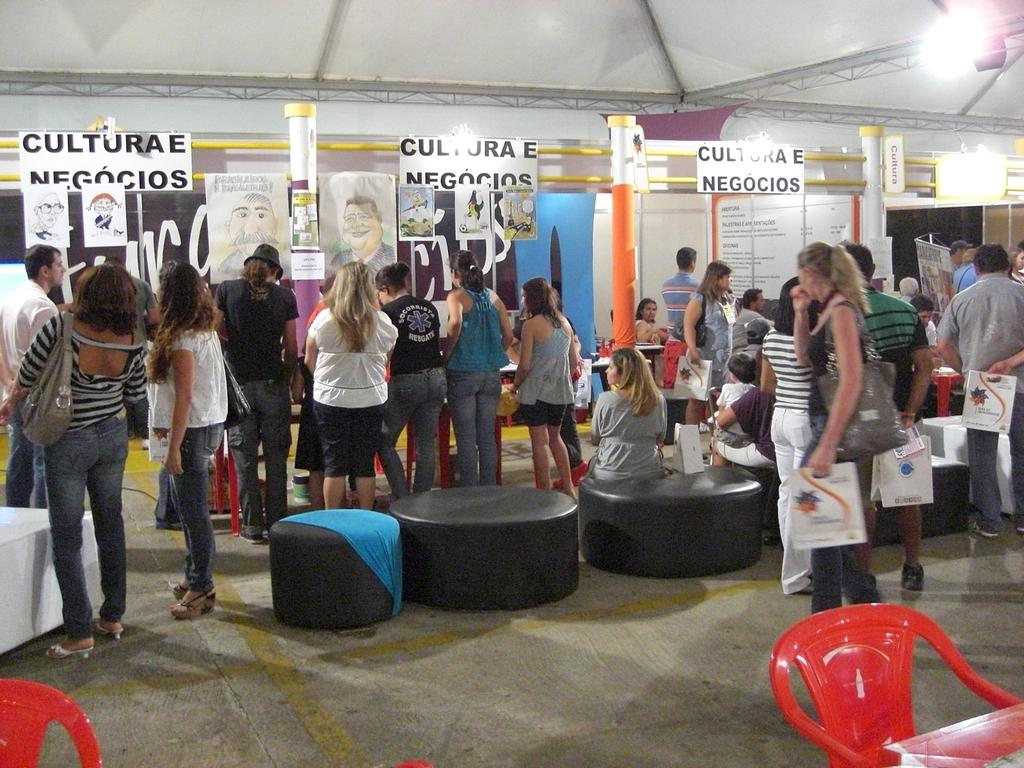What type of furniture is present in the image? There are chairs and stools in the image. What are the people in the image doing? There is a group of people standing on the floor. Can you describe the background of the image? In the background, there are posts, name boards, pillars, and lights. How far away is the bread from the cat in the image? There is no bread or cat present in the image. 